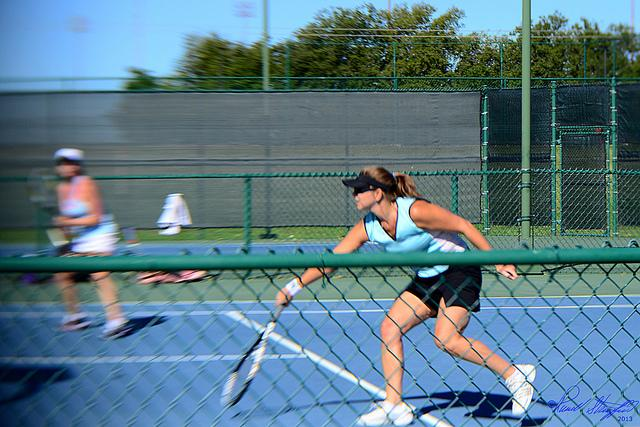What surface are they playing on? Please explain your reasoning. outdoor hard. The surface is hard. 